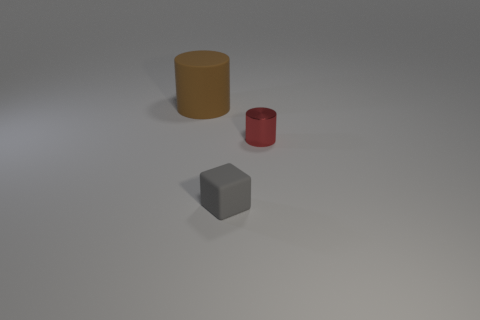What materials do the objects in the image appear to be made of? There are three objects in the image that appear to be made of different materials. The largest cylinder has a matte surface, which could suggest it's made of clay or plastic. The smaller cylinder is red and has a reflective surface, indicative of a metallic material. Lastly, the cube has a uniformly gray color and a matte texture, reminiscent of concrete or stone. 